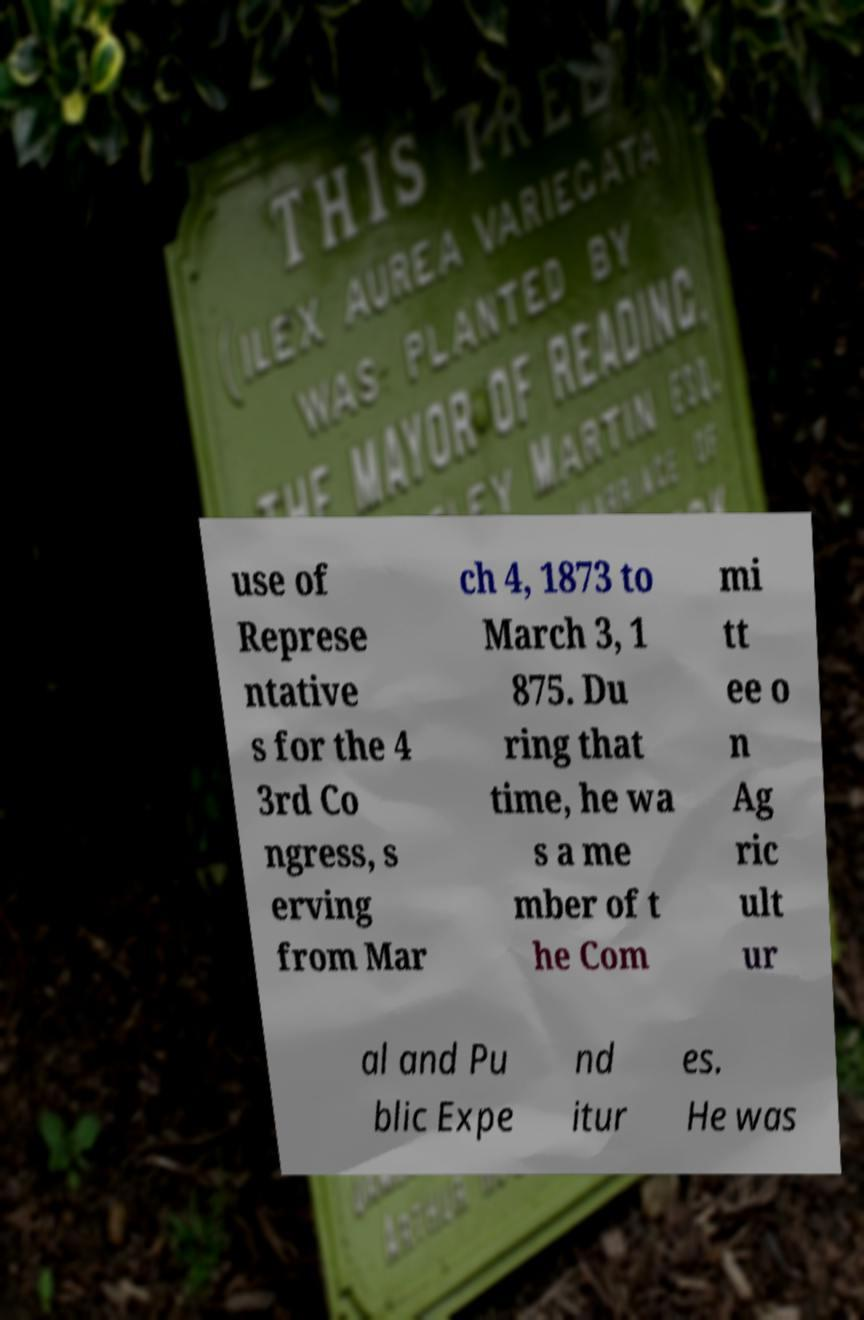Can you read and provide the text displayed in the image?This photo seems to have some interesting text. Can you extract and type it out for me? use of Represe ntative s for the 4 3rd Co ngress, s erving from Mar ch 4, 1873 to March 3, 1 875. Du ring that time, he wa s a me mber of t he Com mi tt ee o n Ag ric ult ur al and Pu blic Expe nd itur es. He was 